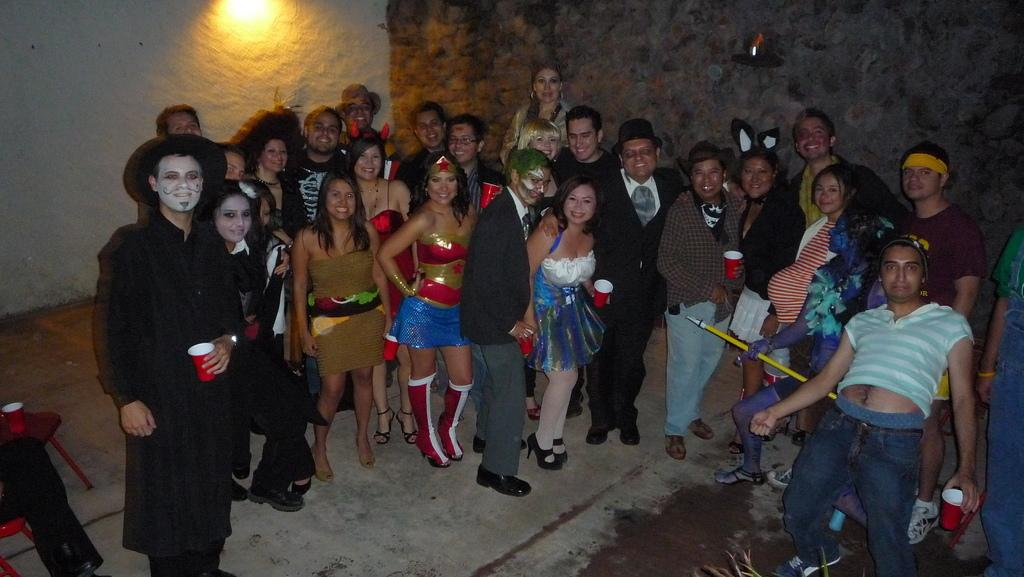How many people are in the image? There is a group of people in the image. What are the people doing in the image? The people are standing and taking a photograph. How are the people dressed in the image? The people are dressed in different manners. What type of jewel can be seen on the forehead of one of the people in the image? There is no jewel visible on anyone's forehead in the image. 